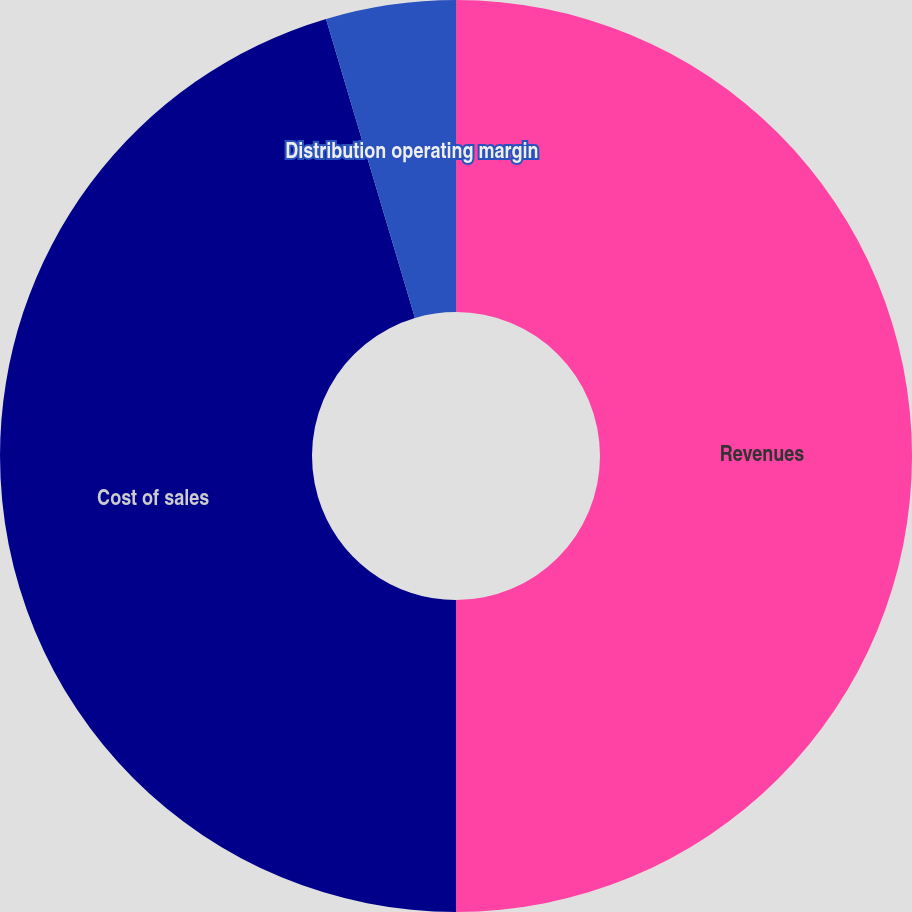Convert chart. <chart><loc_0><loc_0><loc_500><loc_500><pie_chart><fcel>Revenues<fcel>Cost of sales<fcel>Distribution operating margin<nl><fcel>50.0%<fcel>45.4%<fcel>4.6%<nl></chart> 